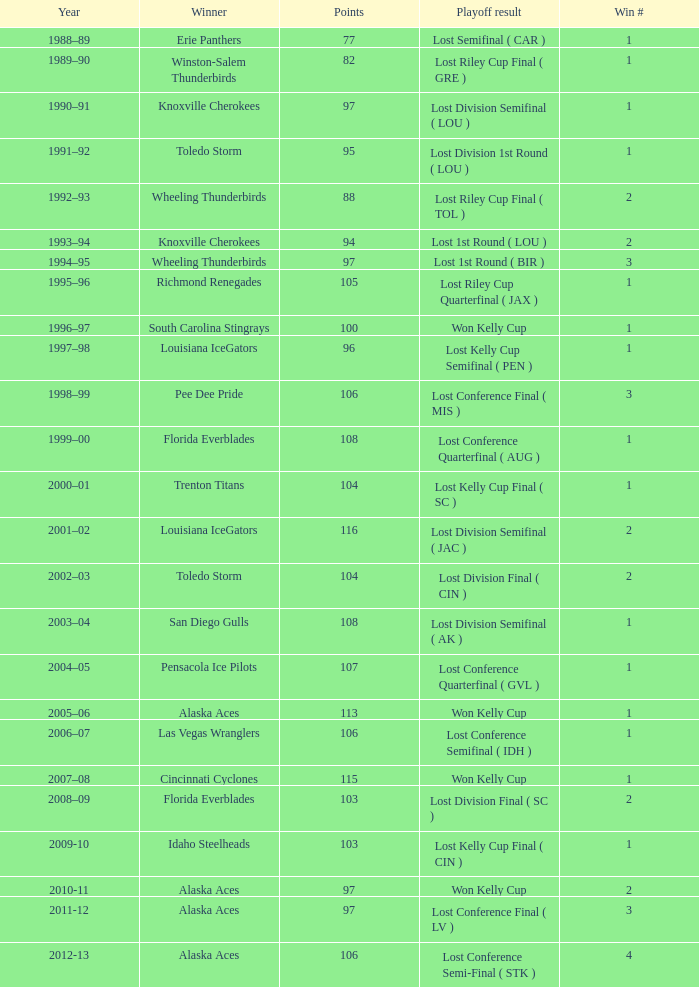What is the playoff result for alaska aces during the 2011-12 season when they have multiple wins and score less than 106 points? Lost Conference Final ( LV ). 